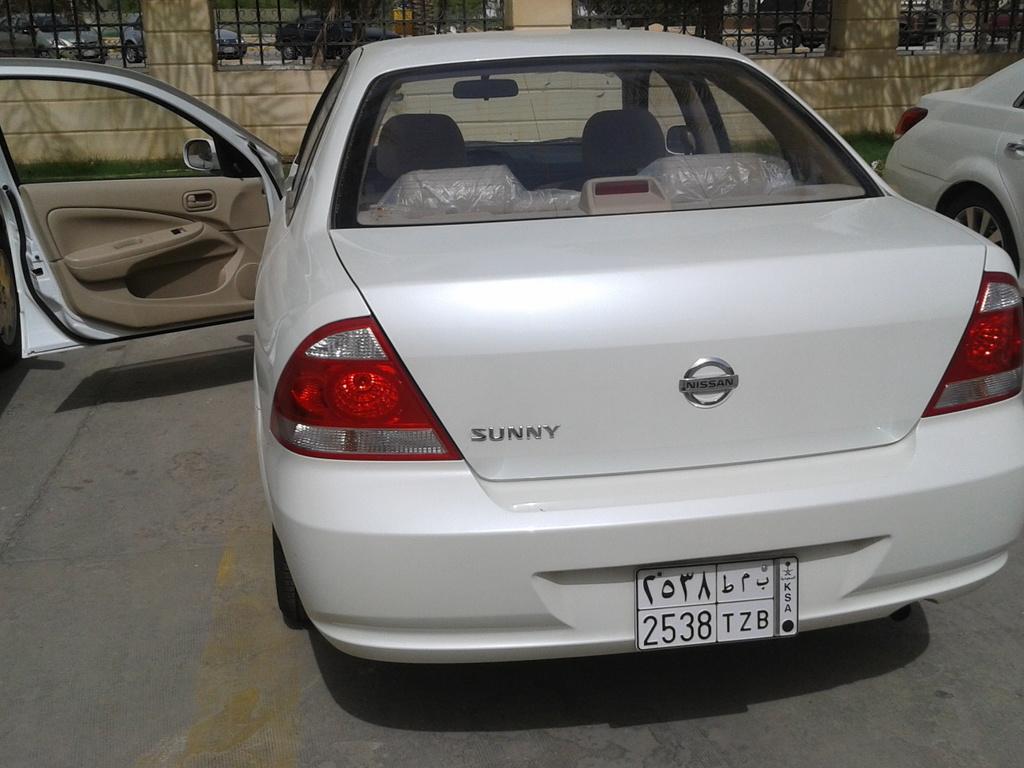Can you describe this image briefly? There is a car with a number plate. It's door is opened. In the back there's a wall with railings. Also there is a car on the right side. 